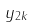<formula> <loc_0><loc_0><loc_500><loc_500>y _ { 2 k }</formula> 